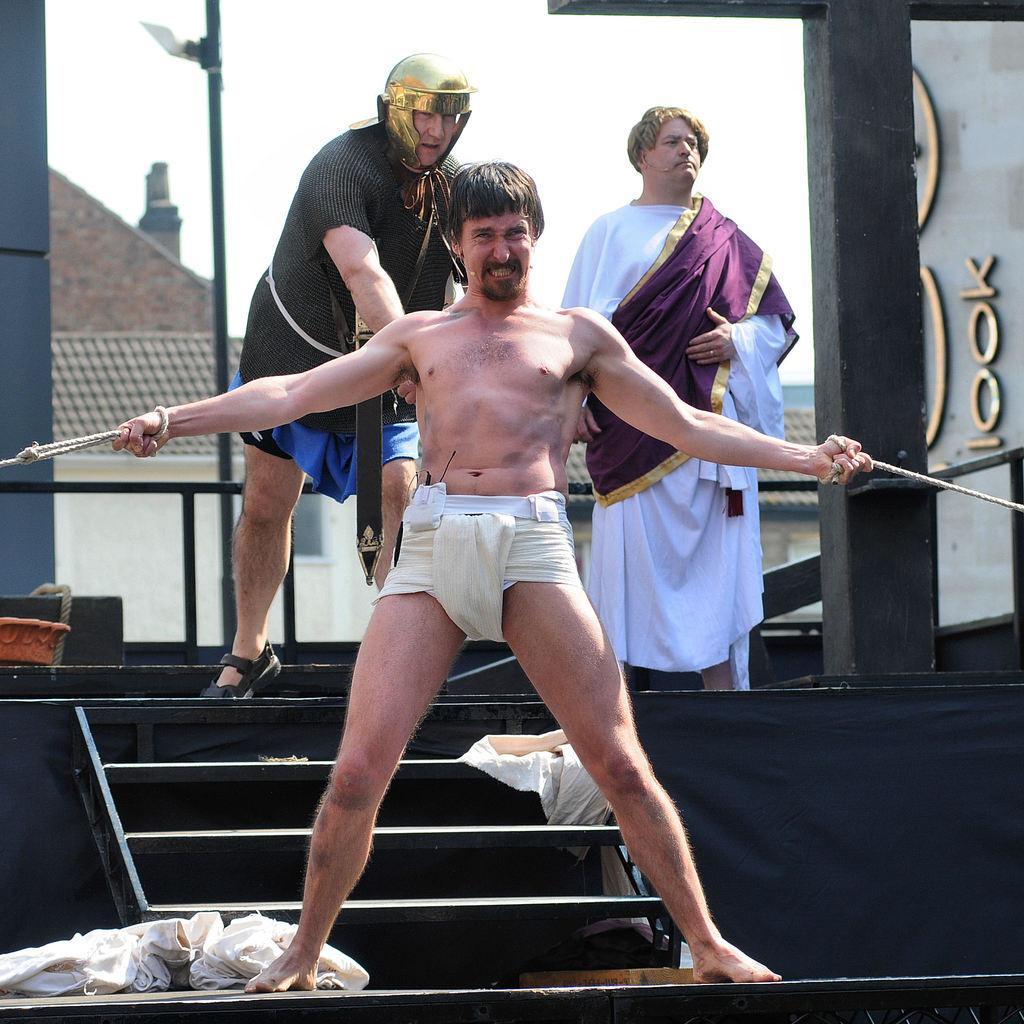In one or two sentences, can you explain what this image depicts? In this image we can see a person holding ropes. In the back there are clothes. Also there are steps. And there are two persons. One person is wearing a helmet. In the background there is a building. Also there is a pole. On the right side there is a pillar. And there is sky. 